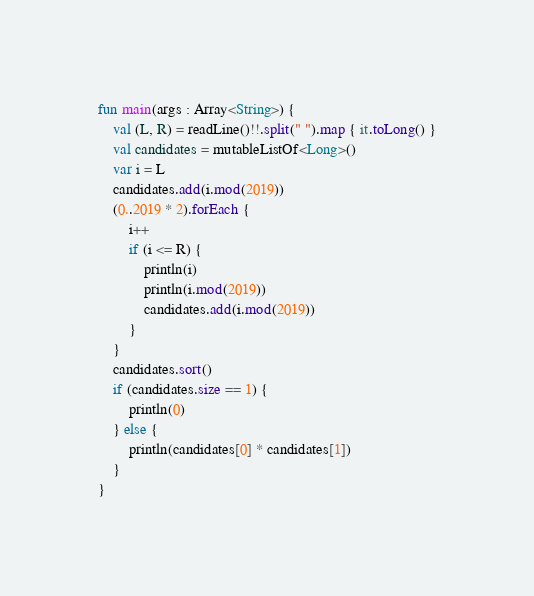Convert code to text. <code><loc_0><loc_0><loc_500><loc_500><_Kotlin_>fun main(args : Array<String>) {
    val (L, R) = readLine()!!.split(" ").map { it.toLong() }
    val candidates = mutableListOf<Long>()
    var i = L
    candidates.add(i.mod(2019))
    (0..2019 * 2).forEach {
        i++
        if (i <= R) {
            println(i)
            println(i.mod(2019))
            candidates.add(i.mod(2019))
        }
    }
    candidates.sort()
    if (candidates.size == 1) {
        println(0)
    } else {
        println(candidates[0] * candidates[1])
    }
}</code> 